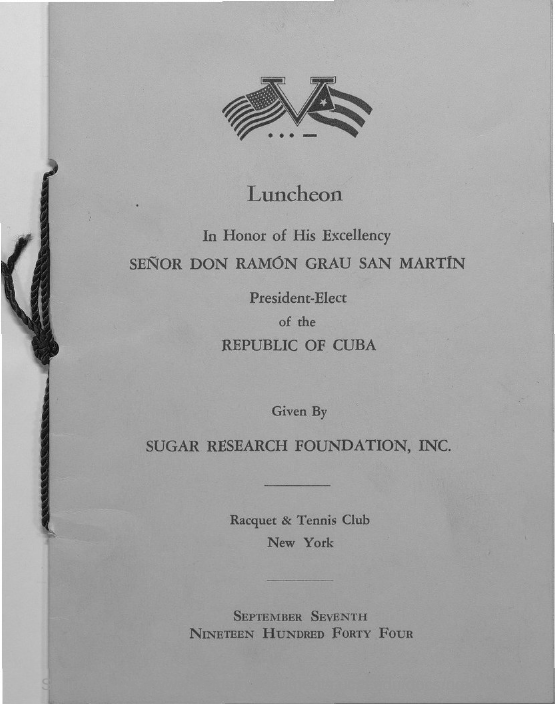Where does SENOR DON RAMON GRAU SAN MARTIN belong to?
Keep it short and to the point. Republic of Cuba. What is the date of luncheon?
Provide a short and direct response. September Seventh Nineteen Hundred Forty Four. 